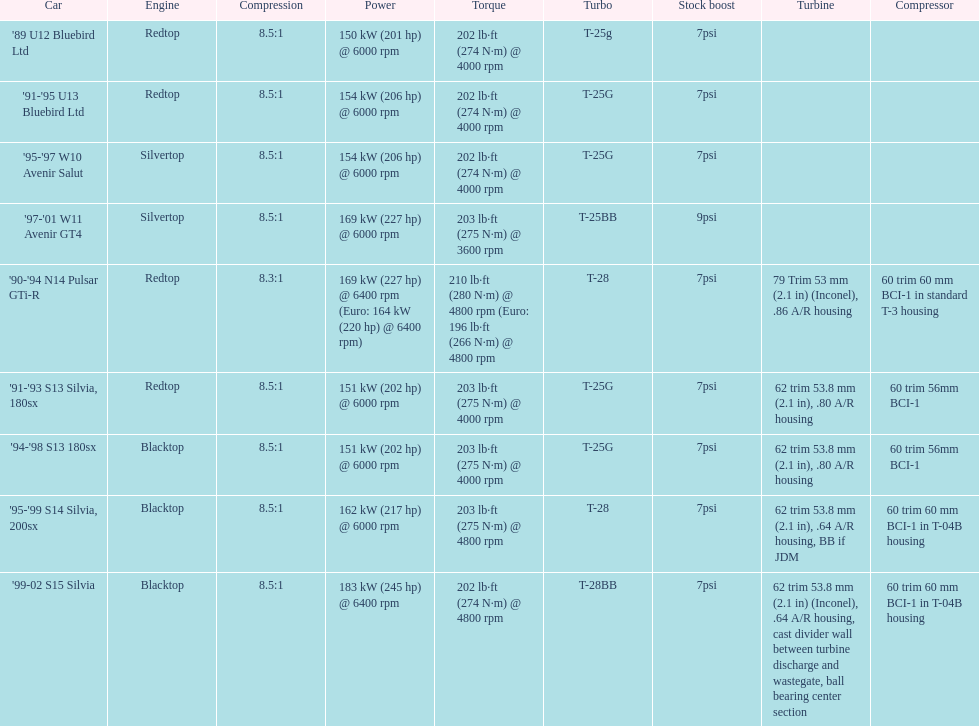Which engine has the smallest compression rate? '90-'94 N14 Pulsar GTi-R. 